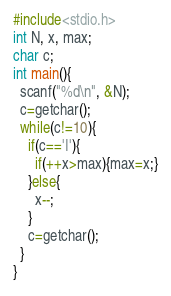<code> <loc_0><loc_0><loc_500><loc_500><_C_>#include<stdio.h>
int N, x, max;
char c;
int main(){
  scanf("%d\n", &N);
  c=getchar();
  while(c!=10){
    if(c=='I'){
      if(++x>max){max=x;}
    }else{
      x--;
    }
    c=getchar();
  }
}
</code> 